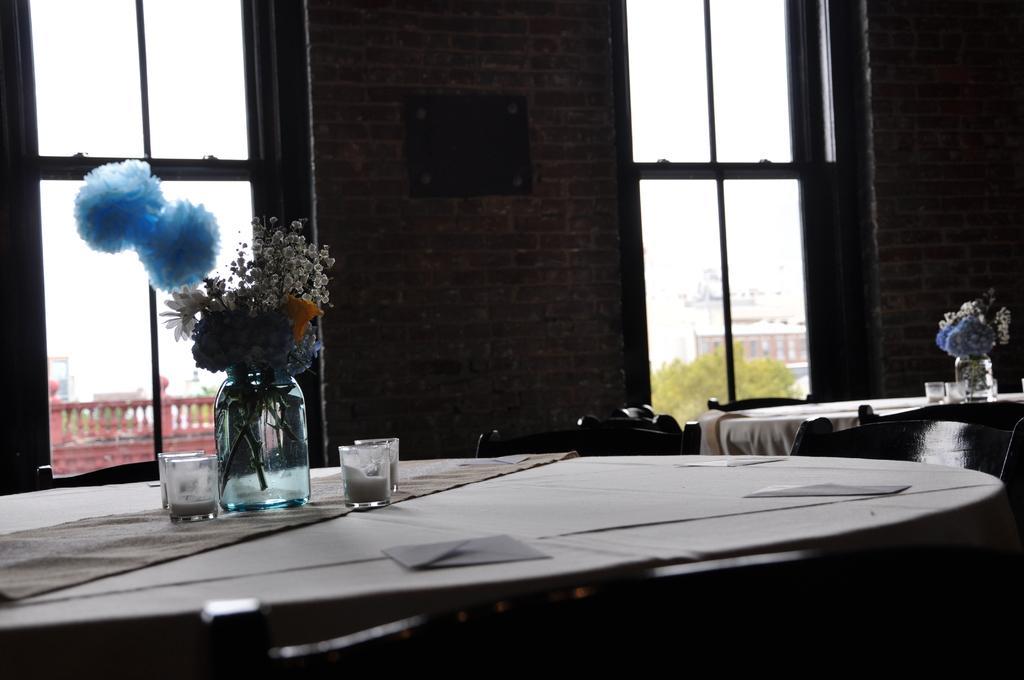How would you summarize this image in a sentence or two? In the picture there are two empty dining tables, on the tables there are flowers vases and candles, in the background there are two windows in between a brick wall. 